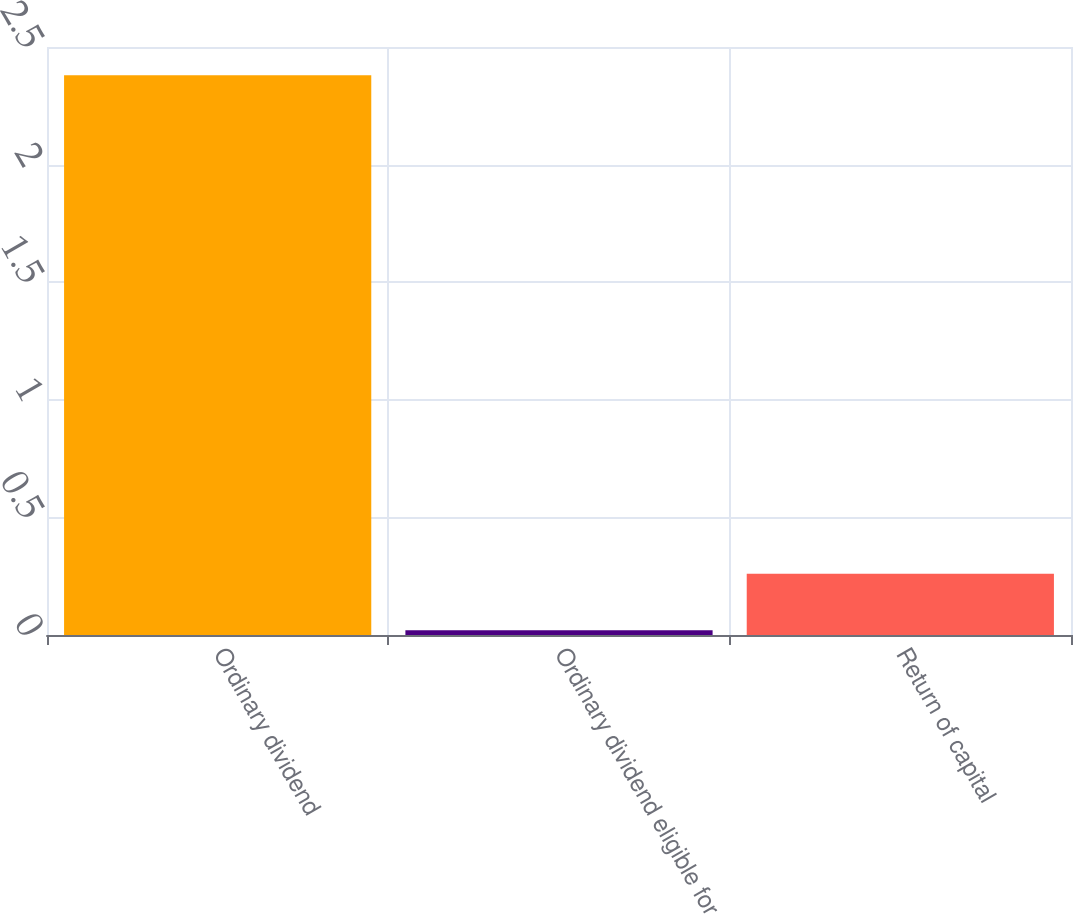Convert chart to OTSL. <chart><loc_0><loc_0><loc_500><loc_500><bar_chart><fcel>Ordinary dividend<fcel>Ordinary dividend eligible for<fcel>Return of capital<nl><fcel>2.38<fcel>0.02<fcel>0.26<nl></chart> 